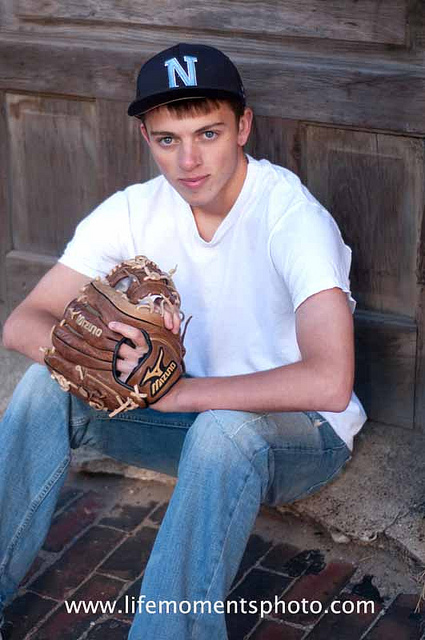Identify the text contained in this image. N www.lifemomentsphoto.com 